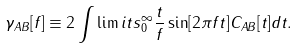Convert formula to latex. <formula><loc_0><loc_0><loc_500><loc_500>\gamma _ { A B } [ f ] \equiv 2 \int \lim i t s _ { 0 } ^ { \infty } { \frac { t } { f } } \sin [ 2 \pi f t ] C _ { A B } [ t ] d t .</formula> 